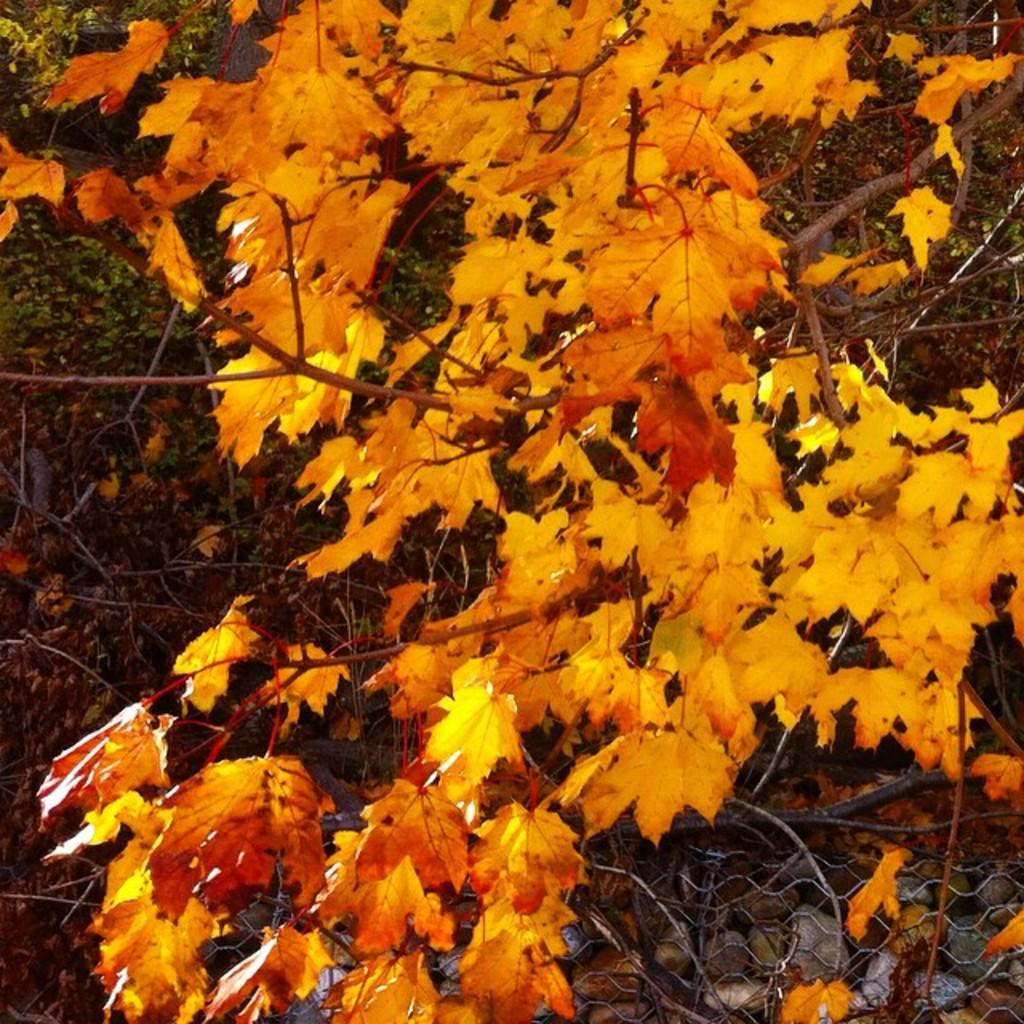What color are the leaves in the image? The leaves in the image are orange. What can be seen in the background of the image? There are trees visible in the background of the image. What is located at the bottom of the image? There is fencing at the bottom of the image. What type of fruit is hanging from the trees in the image? There is no fruit visible in the image; only orange leaves and trees are present. Is there a stove visible in the image? No, there is no stove present in the image. 